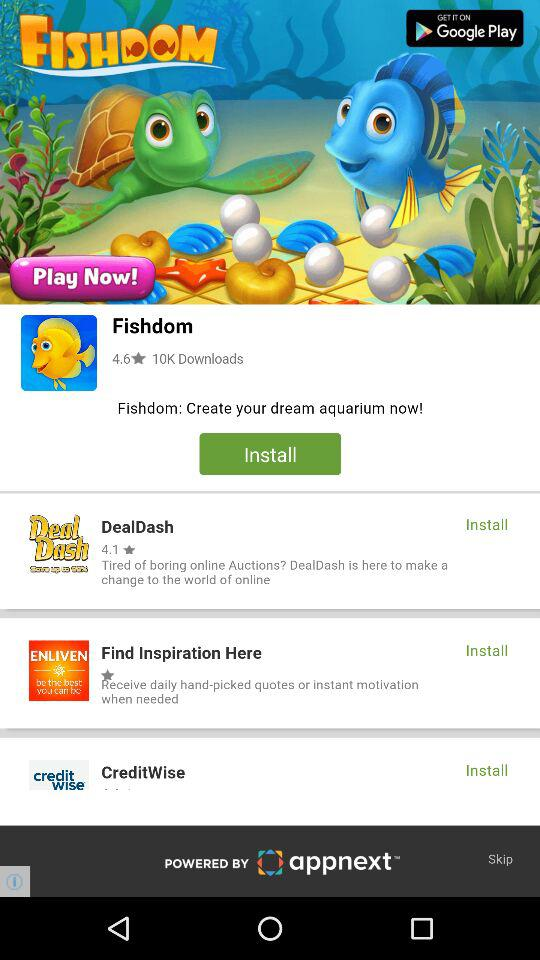What is the rating of "DealDash"? The rating is 4.1 stars. 